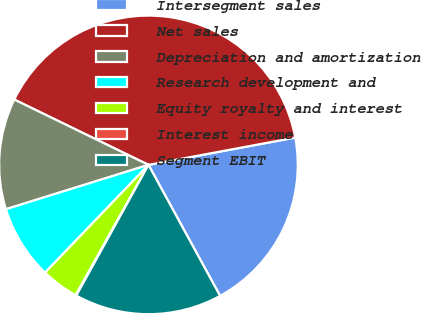Convert chart to OTSL. <chart><loc_0><loc_0><loc_500><loc_500><pie_chart><fcel>Intersegment sales<fcel>Net sales<fcel>Depreciation and amortization<fcel>Research development and<fcel>Equity royalty and interest<fcel>Interest income<fcel>Segment EBIT<nl><fcel>19.97%<fcel>39.86%<fcel>12.01%<fcel>8.03%<fcel>4.06%<fcel>0.08%<fcel>15.99%<nl></chart> 